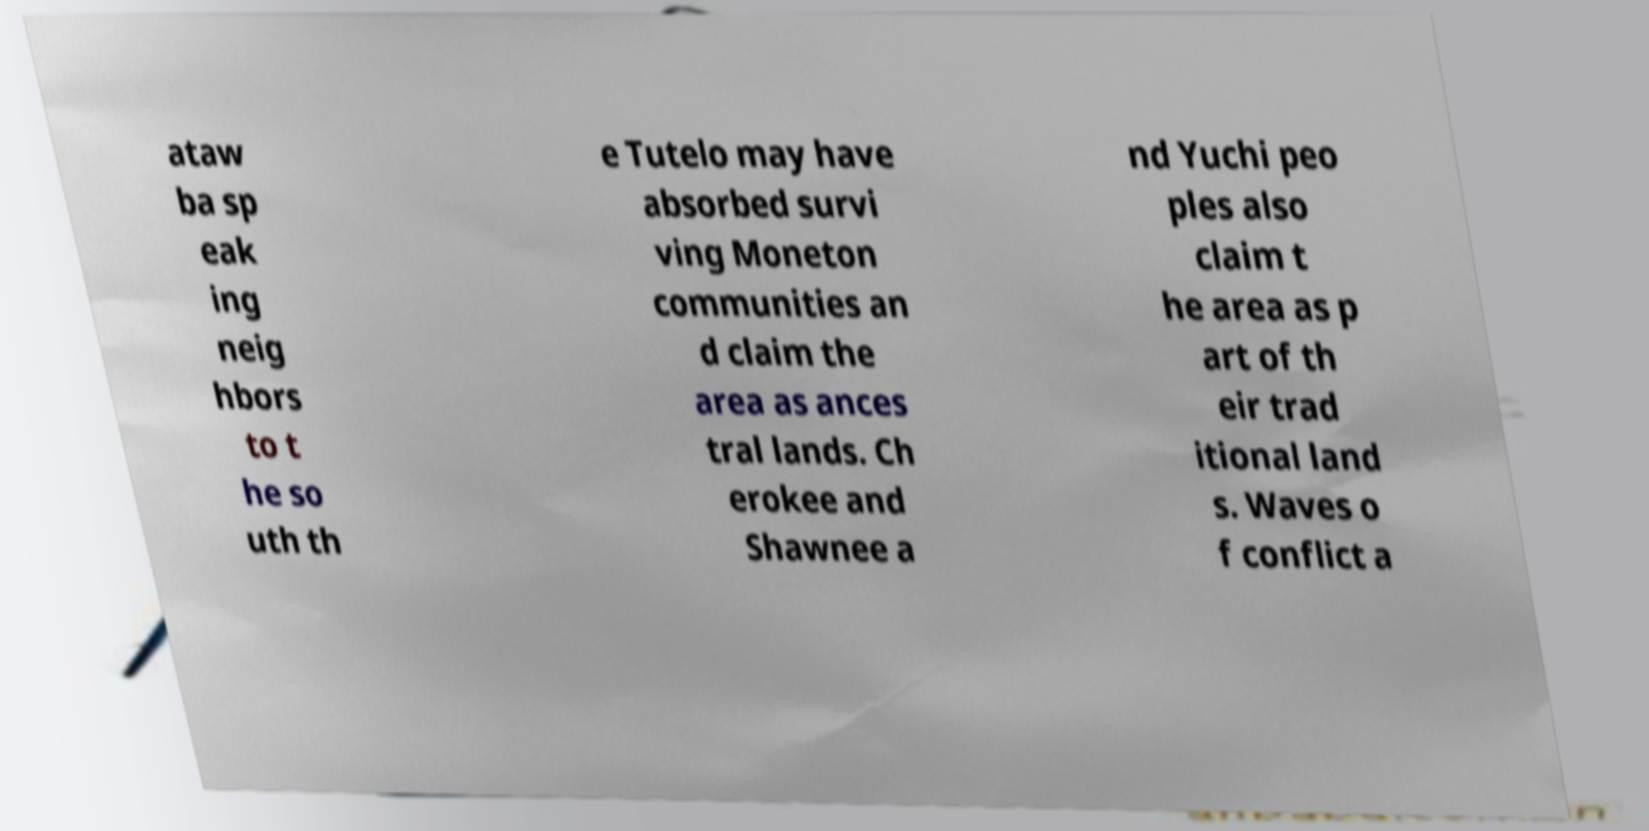I need the written content from this picture converted into text. Can you do that? ataw ba sp eak ing neig hbors to t he so uth th e Tutelo may have absorbed survi ving Moneton communities an d claim the area as ances tral lands. Ch erokee and Shawnee a nd Yuchi peo ples also claim t he area as p art of th eir trad itional land s. Waves o f conflict a 